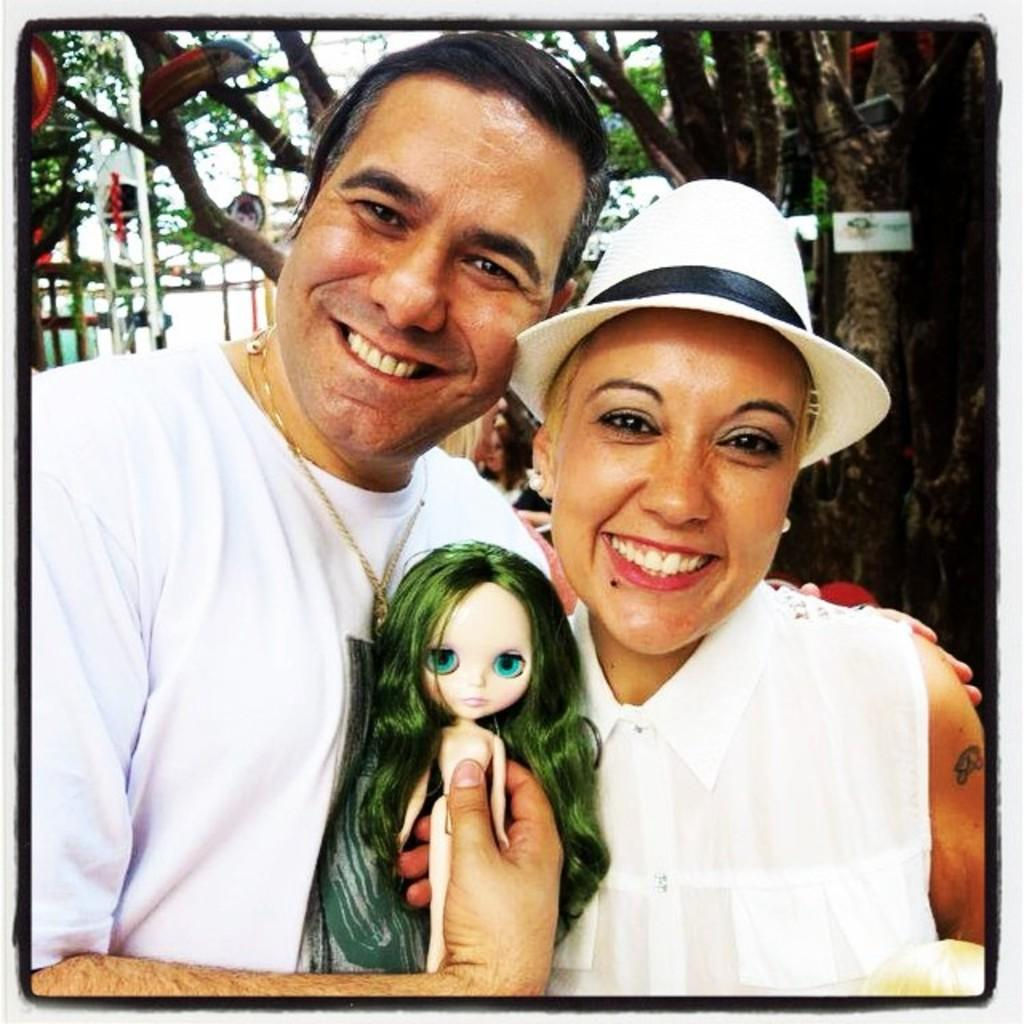What is the person holding in the image? The person is holding a doll in the image. What is the facial expression of the person holding the doll? The person is smiling. Can you describe the woman in the image? There is a woman in the image, and she is also smiling. What can be seen in the background of the image? There is a metal fence and trees in the background of the image. What type of milk is being poured into the doll's mouth in the image? There is no milk or doll's mouth present in the image; it features a person holding a doll and a woman, both smiling. 